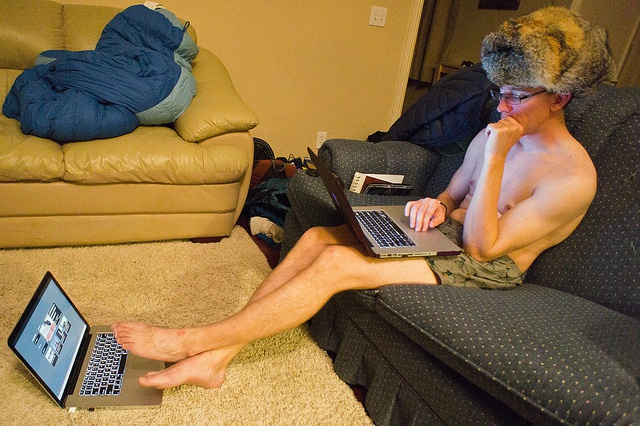Describe the objects in this image and their specific colors. I can see couch in olive and orange tones, couch in olive, black, and gray tones, people in olive, orange, tan, and black tones, laptop in olive, black, and darkgray tones, and laptop in olive, black, tan, and gray tones in this image. 